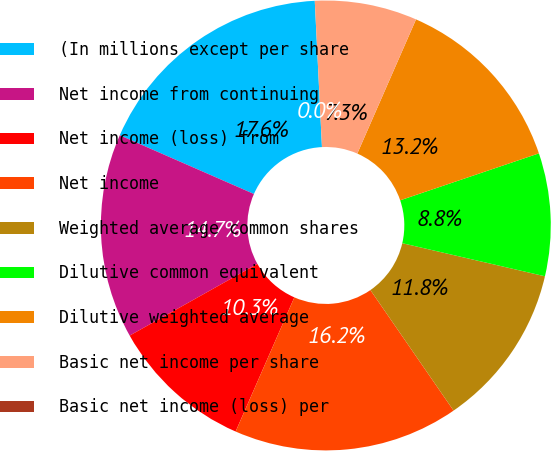Convert chart to OTSL. <chart><loc_0><loc_0><loc_500><loc_500><pie_chart><fcel>(In millions except per share<fcel>Net income from continuing<fcel>Net income (loss) from<fcel>Net income<fcel>Weighted average common shares<fcel>Dilutive common equivalent<fcel>Dilutive weighted average<fcel>Basic net income per share<fcel>Basic net income (loss) per<nl><fcel>17.65%<fcel>14.71%<fcel>10.29%<fcel>16.18%<fcel>11.76%<fcel>8.82%<fcel>13.24%<fcel>7.35%<fcel>0.0%<nl></chart> 